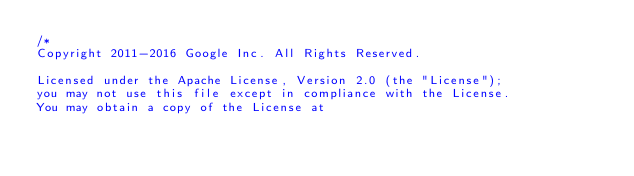Convert code to text. <code><loc_0><loc_0><loc_500><loc_500><_Java_>/*
Copyright 2011-2016 Google Inc. All Rights Reserved.

Licensed under the Apache License, Version 2.0 (the "License");
you may not use this file except in compliance with the License.
You may obtain a copy of the License at
</code> 